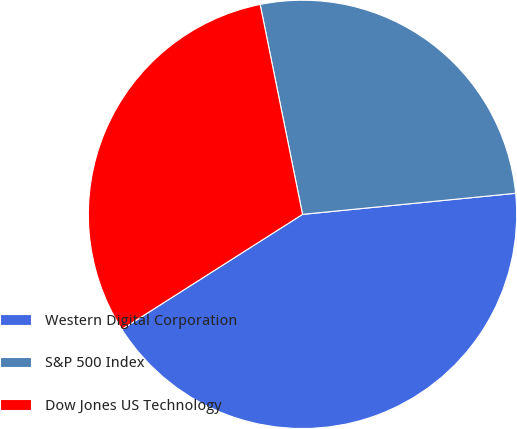Convert chart. <chart><loc_0><loc_0><loc_500><loc_500><pie_chart><fcel>Western Digital Corporation<fcel>S&P 500 Index<fcel>Dow Jones US Technology<nl><fcel>42.55%<fcel>26.6%<fcel>30.85%<nl></chart> 